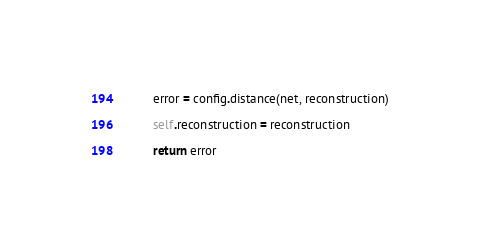<code> <loc_0><loc_0><loc_500><loc_500><_Python_>        error = config.distance(net, reconstruction)

        self.reconstruction = reconstruction

        return error


</code> 